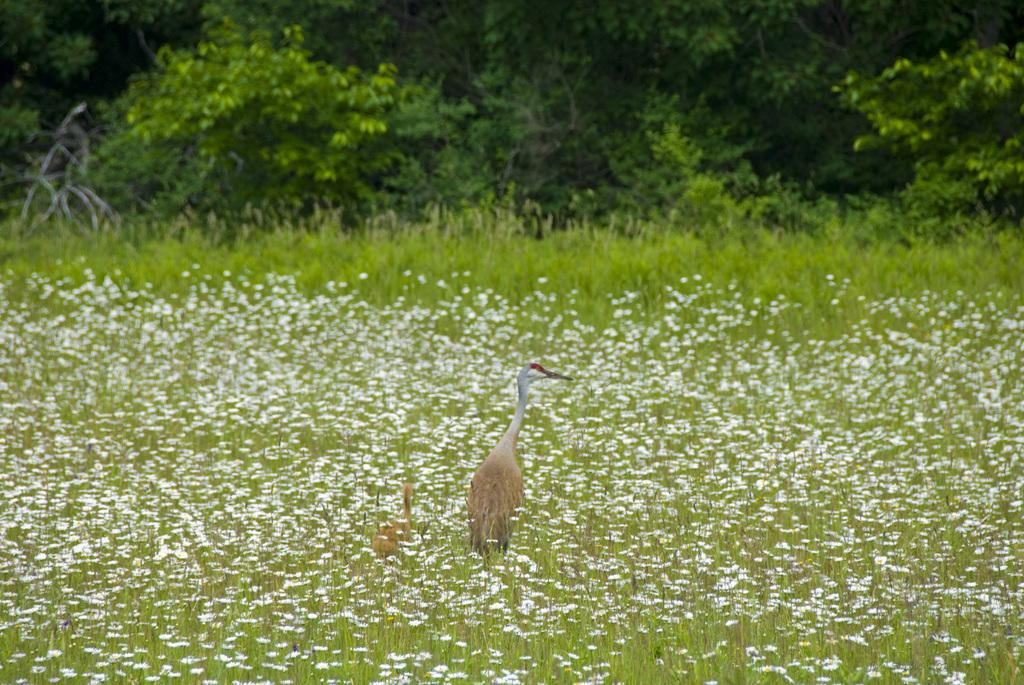What type of plants can be seen in the image? There are plants with flowers in the image. Where are the plants located in the image? The plants are at the bottom of the image. What is the main object in the middle of the image? There is a crane in the middle of the image. What can be seen in the background of the image? There are trees in the background of the image. What type of drum can be seen in the image? There is no drum present in the image. What is the profit of the plants in the image? The image does not provide information about the profit of the plants, as it is focused on their appearance and location. 